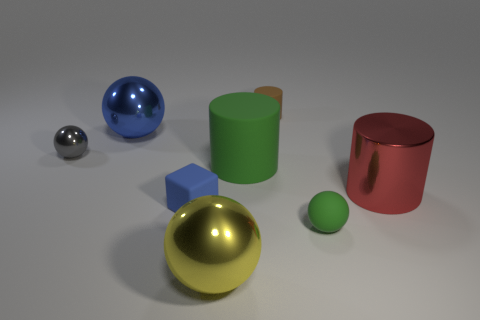Subtract 1 balls. How many balls are left? 3 Add 2 yellow metallic cubes. How many objects exist? 10 Subtract all cylinders. How many objects are left? 5 Subtract all red metal blocks. Subtract all big green matte objects. How many objects are left? 7 Add 3 tiny metallic balls. How many tiny metallic balls are left? 4 Add 7 large yellow objects. How many large yellow objects exist? 8 Subtract 0 gray cylinders. How many objects are left? 8 